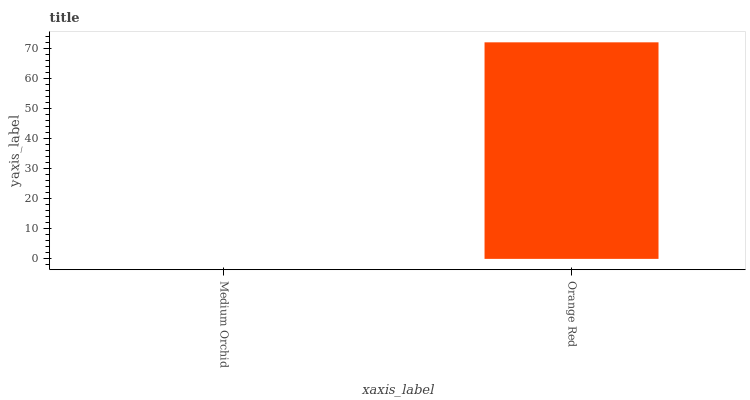Is Medium Orchid the minimum?
Answer yes or no. Yes. Is Orange Red the maximum?
Answer yes or no. Yes. Is Orange Red the minimum?
Answer yes or no. No. Is Orange Red greater than Medium Orchid?
Answer yes or no. Yes. Is Medium Orchid less than Orange Red?
Answer yes or no. Yes. Is Medium Orchid greater than Orange Red?
Answer yes or no. No. Is Orange Red less than Medium Orchid?
Answer yes or no. No. Is Orange Red the high median?
Answer yes or no. Yes. Is Medium Orchid the low median?
Answer yes or no. Yes. Is Medium Orchid the high median?
Answer yes or no. No. Is Orange Red the low median?
Answer yes or no. No. 